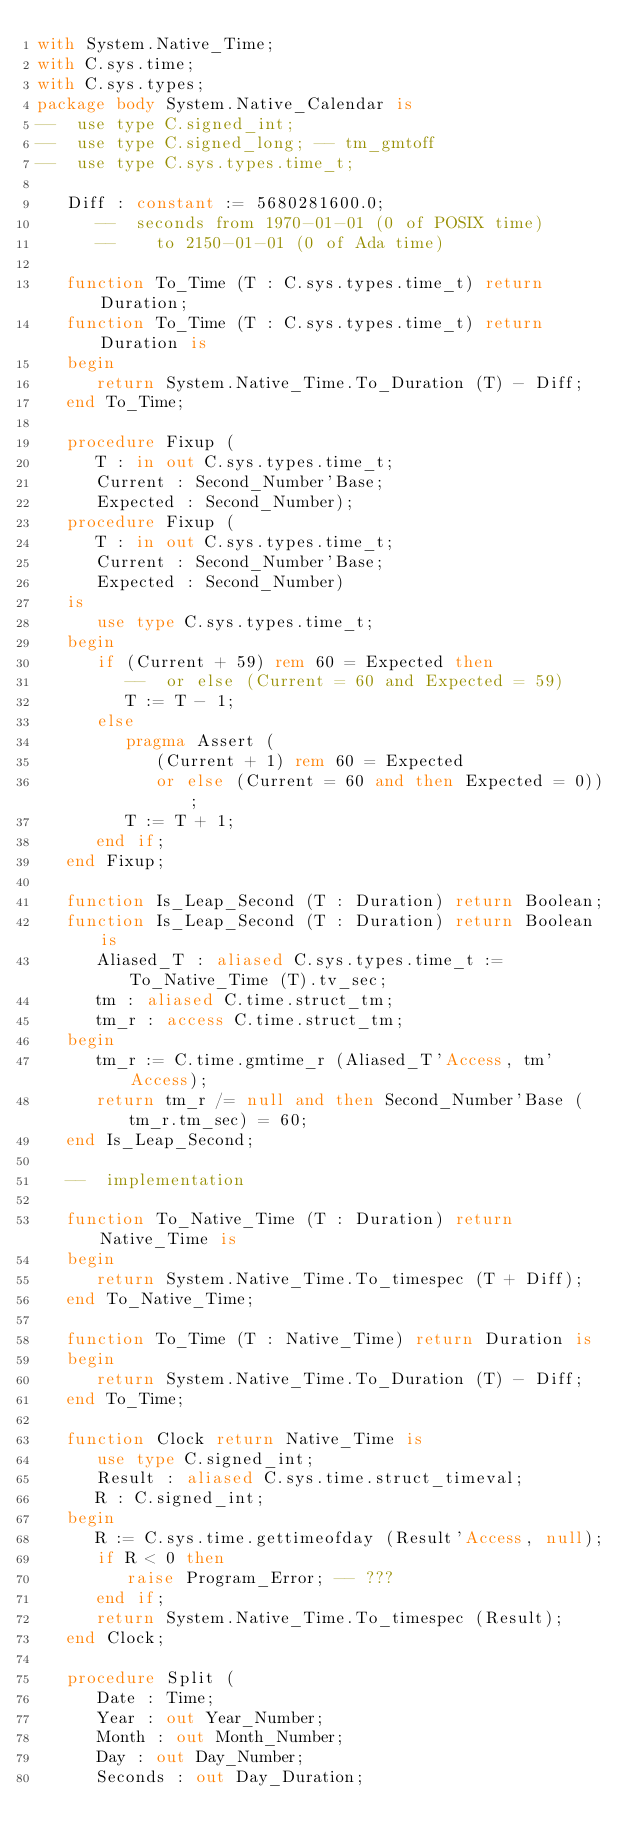Convert code to text. <code><loc_0><loc_0><loc_500><loc_500><_Ada_>with System.Native_Time;
with C.sys.time;
with C.sys.types;
package body System.Native_Calendar is
--  use type C.signed_int;
--  use type C.signed_long; -- tm_gmtoff
--  use type C.sys.types.time_t;

   Diff : constant := 5680281600.0;
      --  seconds from 1970-01-01 (0 of POSIX time)
      --    to 2150-01-01 (0 of Ada time)

   function To_Time (T : C.sys.types.time_t) return Duration;
   function To_Time (T : C.sys.types.time_t) return Duration is
   begin
      return System.Native_Time.To_Duration (T) - Diff;
   end To_Time;

   procedure Fixup (
      T : in out C.sys.types.time_t;
      Current : Second_Number'Base;
      Expected : Second_Number);
   procedure Fixup (
      T : in out C.sys.types.time_t;
      Current : Second_Number'Base;
      Expected : Second_Number)
   is
      use type C.sys.types.time_t;
   begin
      if (Current + 59) rem 60 = Expected then
         --  or else (Current = 60 and Expected = 59)
         T := T - 1;
      else
         pragma Assert (
            (Current + 1) rem 60 = Expected
            or else (Current = 60 and then Expected = 0));
         T := T + 1;
      end if;
   end Fixup;

   function Is_Leap_Second (T : Duration) return Boolean;
   function Is_Leap_Second (T : Duration) return Boolean is
      Aliased_T : aliased C.sys.types.time_t := To_Native_Time (T).tv_sec;
      tm : aliased C.time.struct_tm;
      tm_r : access C.time.struct_tm;
   begin
      tm_r := C.time.gmtime_r (Aliased_T'Access, tm'Access);
      return tm_r /= null and then Second_Number'Base (tm_r.tm_sec) = 60;
   end Is_Leap_Second;

   --  implementation

   function To_Native_Time (T : Duration) return Native_Time is
   begin
      return System.Native_Time.To_timespec (T + Diff);
   end To_Native_Time;

   function To_Time (T : Native_Time) return Duration is
   begin
      return System.Native_Time.To_Duration (T) - Diff;
   end To_Time;

   function Clock return Native_Time is
      use type C.signed_int;
      Result : aliased C.sys.time.struct_timeval;
      R : C.signed_int;
   begin
      R := C.sys.time.gettimeofday (Result'Access, null);
      if R < 0 then
         raise Program_Error; -- ???
      end if;
      return System.Native_Time.To_timespec (Result);
   end Clock;

   procedure Split (
      Date : Time;
      Year : out Year_Number;
      Month : out Month_Number;
      Day : out Day_Number;
      Seconds : out Day_Duration;</code> 